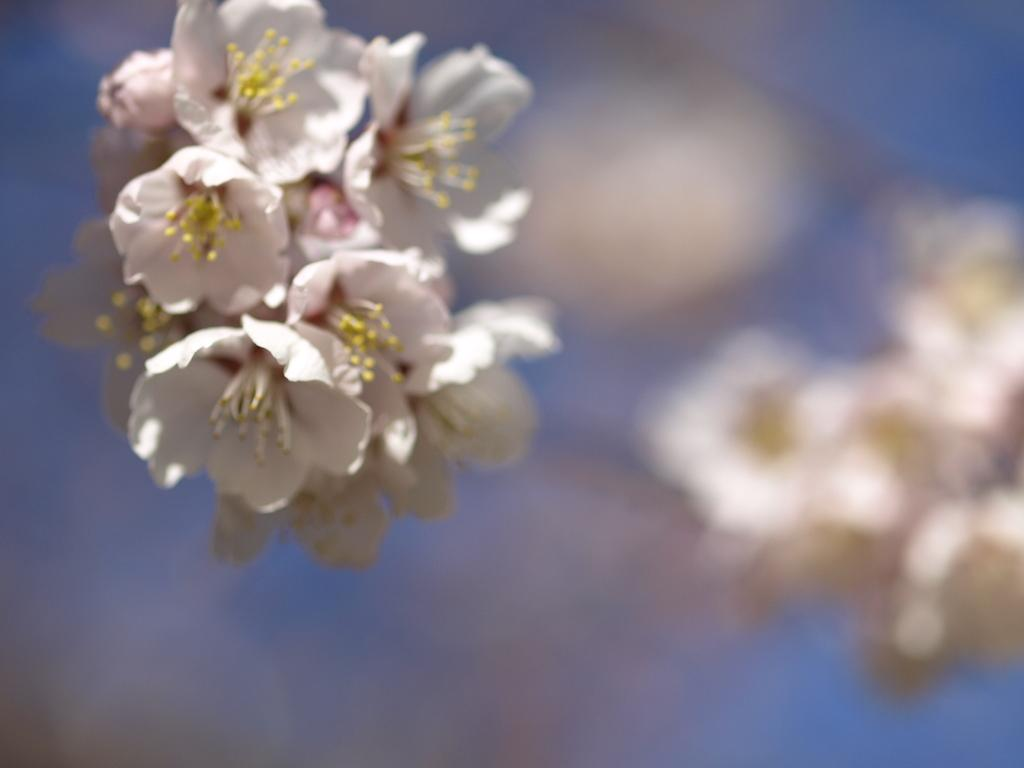What type of flora is present on the left side of the image? There are small flowers on the left side of the image. Can you describe the background of the image? The background of the image is blurry. What trick do the flowers perform in the image? There is no trick being performed by the flowers in the image; they are simply small flowers. 